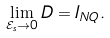Convert formula to latex. <formula><loc_0><loc_0><loc_500><loc_500>\lim _ { \mathcal { E } _ { s } \rightarrow 0 } D = I _ { N Q } .</formula> 